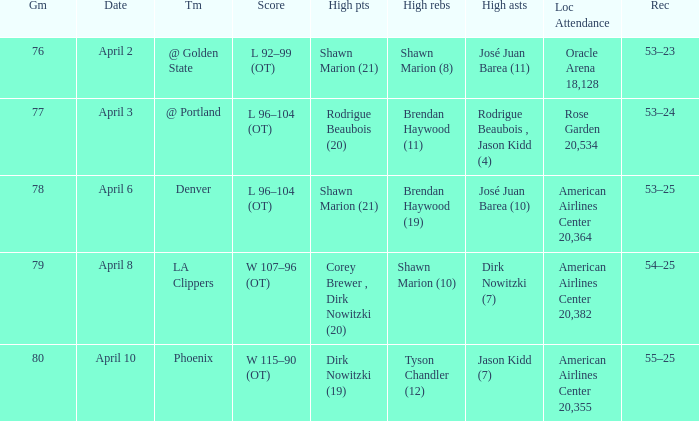What is the game number played on April 3? 77.0. 